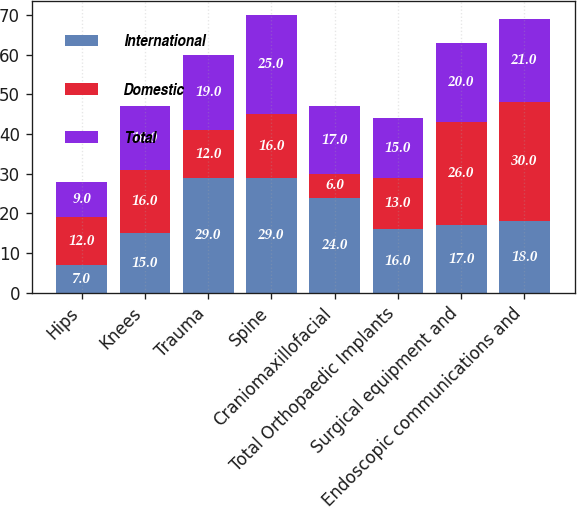<chart> <loc_0><loc_0><loc_500><loc_500><stacked_bar_chart><ecel><fcel>Hips<fcel>Knees<fcel>Trauma<fcel>Spine<fcel>Craniomaxillofacial<fcel>Total Orthopaedic Implants<fcel>Surgical equipment and<fcel>Endoscopic communications and<nl><fcel>International<fcel>7<fcel>15<fcel>29<fcel>29<fcel>24<fcel>16<fcel>17<fcel>18<nl><fcel>Domestic<fcel>12<fcel>16<fcel>12<fcel>16<fcel>6<fcel>13<fcel>26<fcel>30<nl><fcel>Total<fcel>9<fcel>16<fcel>19<fcel>25<fcel>17<fcel>15<fcel>20<fcel>21<nl></chart> 